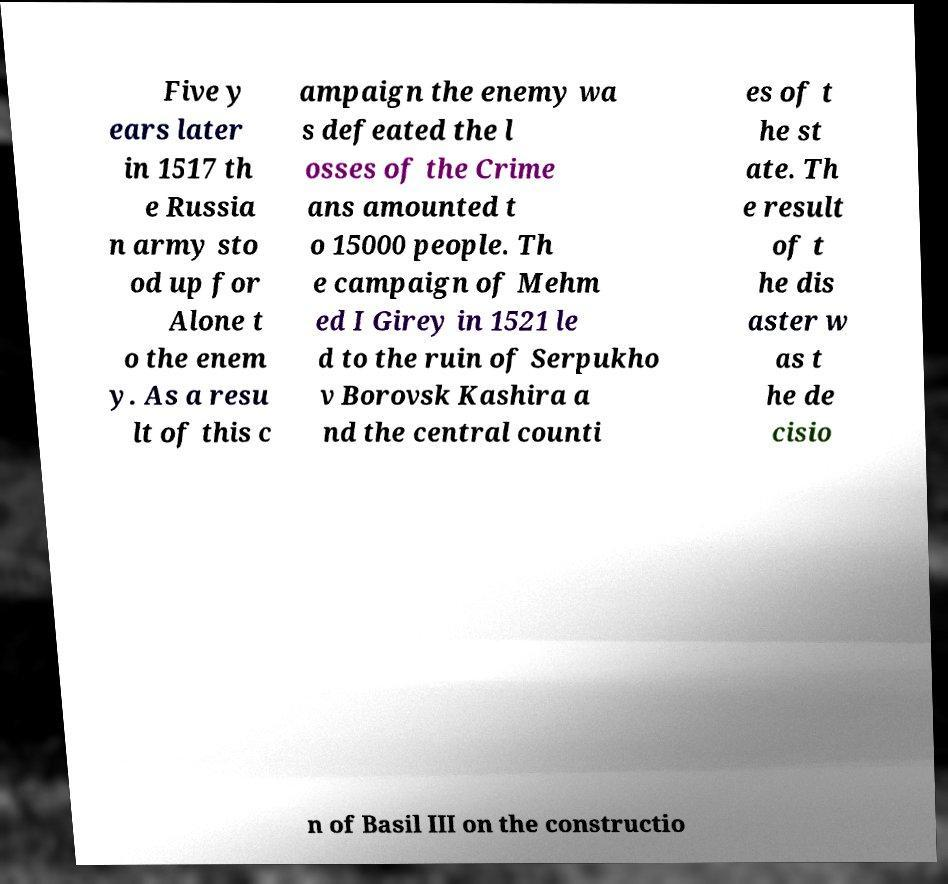What messages or text are displayed in this image? I need them in a readable, typed format. Five y ears later in 1517 th e Russia n army sto od up for Alone t o the enem y. As a resu lt of this c ampaign the enemy wa s defeated the l osses of the Crime ans amounted t o 15000 people. Th e campaign of Mehm ed I Girey in 1521 le d to the ruin of Serpukho v Borovsk Kashira a nd the central counti es of t he st ate. Th e result of t he dis aster w as t he de cisio n of Basil III on the constructio 